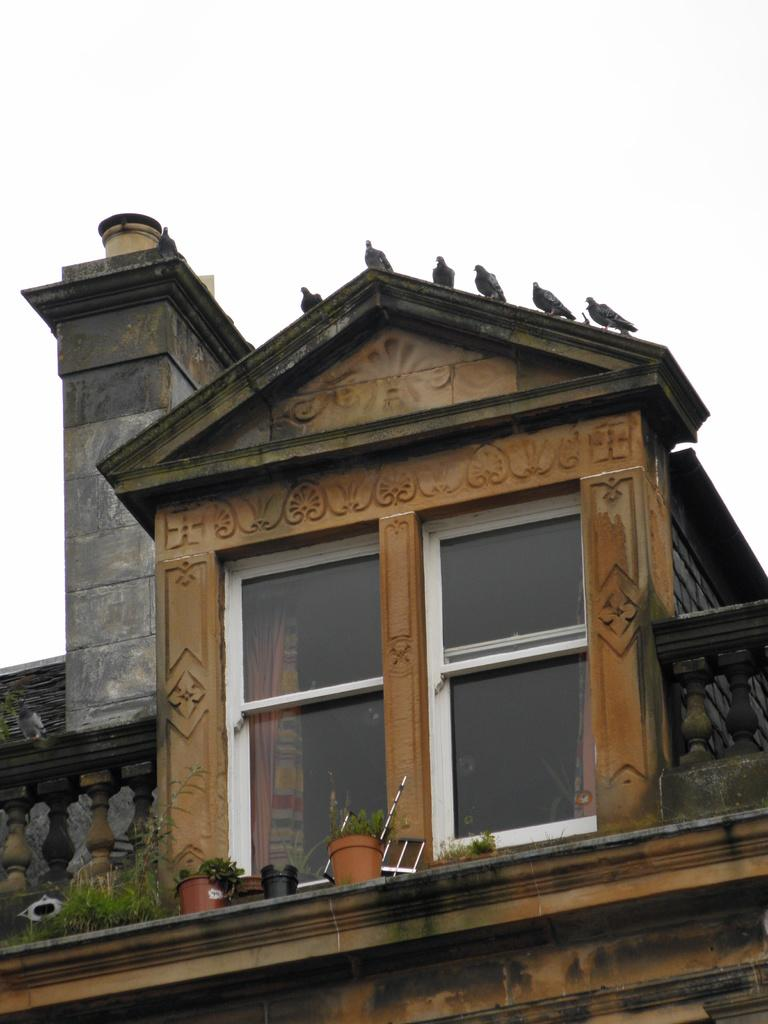What type of structure is present in the image? There is a building in the image. What features can be observed on the building? The building has windows and a railing. What can be seen near the windows of the building? There are pots with plants near the windows. Are there any living creatures present on the building? Yes, there are birds on the building. What is visible in the background of the image? The sky is visible in the background of the image. What type of wine is being served on the building's balcony in the image? There is no wine or balcony present in the image; it features a building with windows, a railing, pots with plants, and birds. How does the glove help the birds maintain their balance on the building? There is no glove or reference to balance in the image; it only shows birds on the building. 